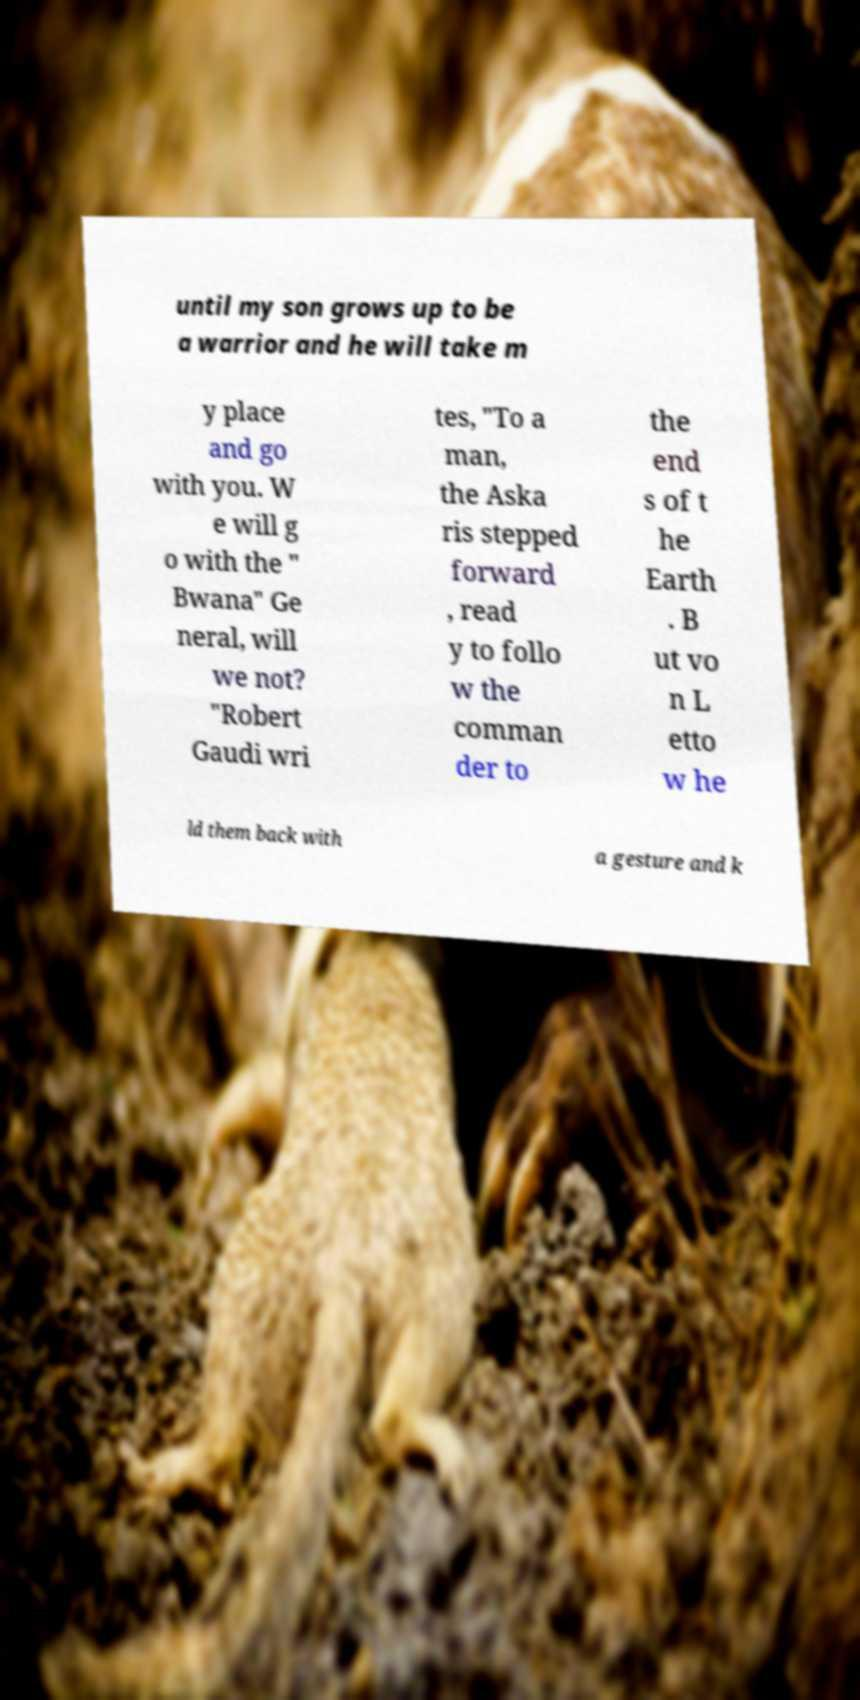Please identify and transcribe the text found in this image. until my son grows up to be a warrior and he will take m y place and go with you. W e will g o with the " Bwana" Ge neral, will we not? "Robert Gaudi wri tes, "To a man, the Aska ris stepped forward , read y to follo w the comman der to the end s of t he Earth . B ut vo n L etto w he ld them back with a gesture and k 